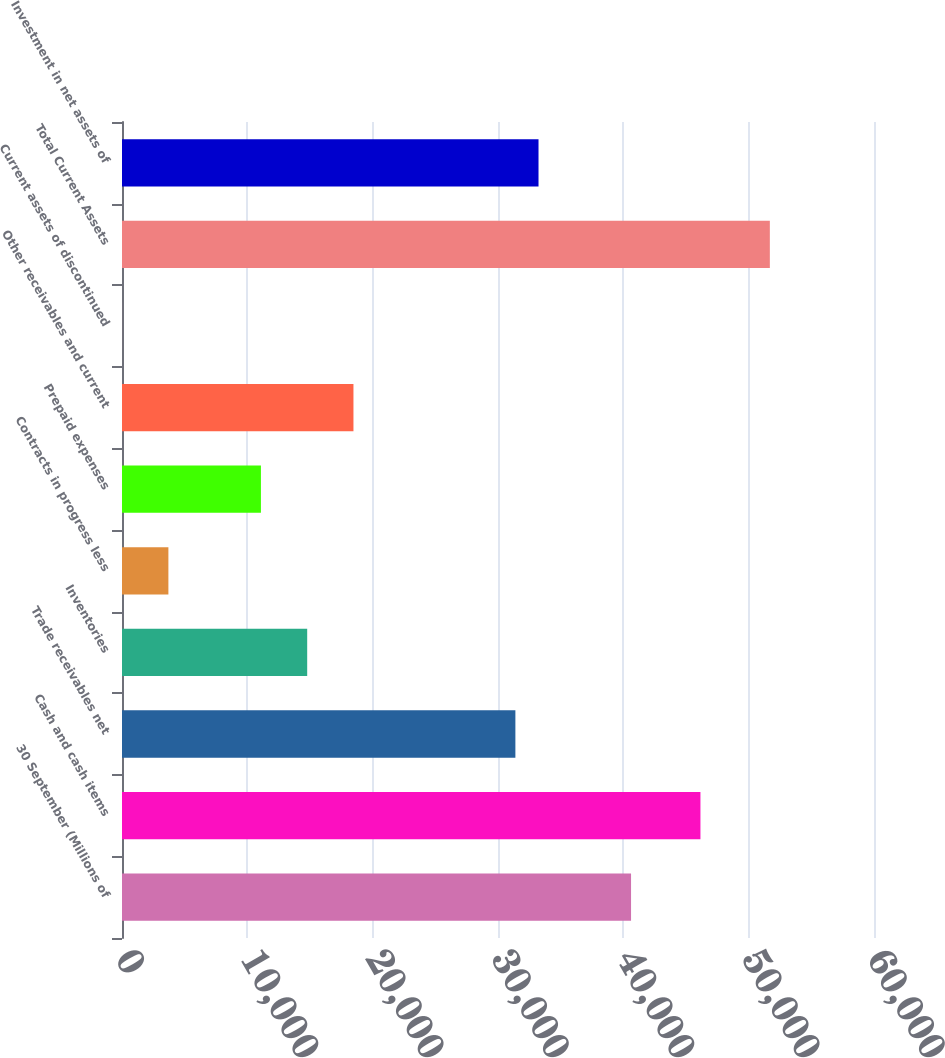<chart> <loc_0><loc_0><loc_500><loc_500><bar_chart><fcel>30 September (Millions of<fcel>Cash and cash items<fcel>Trade receivables net<fcel>Inventories<fcel>Contracts in progress less<fcel>Prepaid expenses<fcel>Other receivables and current<fcel>Current assets of discontinued<fcel>Total Current Assets<fcel>Investment in net assets of<nl><fcel>40615.6<fcel>46152.7<fcel>31387.1<fcel>14775.8<fcel>3701.6<fcel>11084.4<fcel>18467.2<fcel>10.2<fcel>51689.8<fcel>33232.8<nl></chart> 